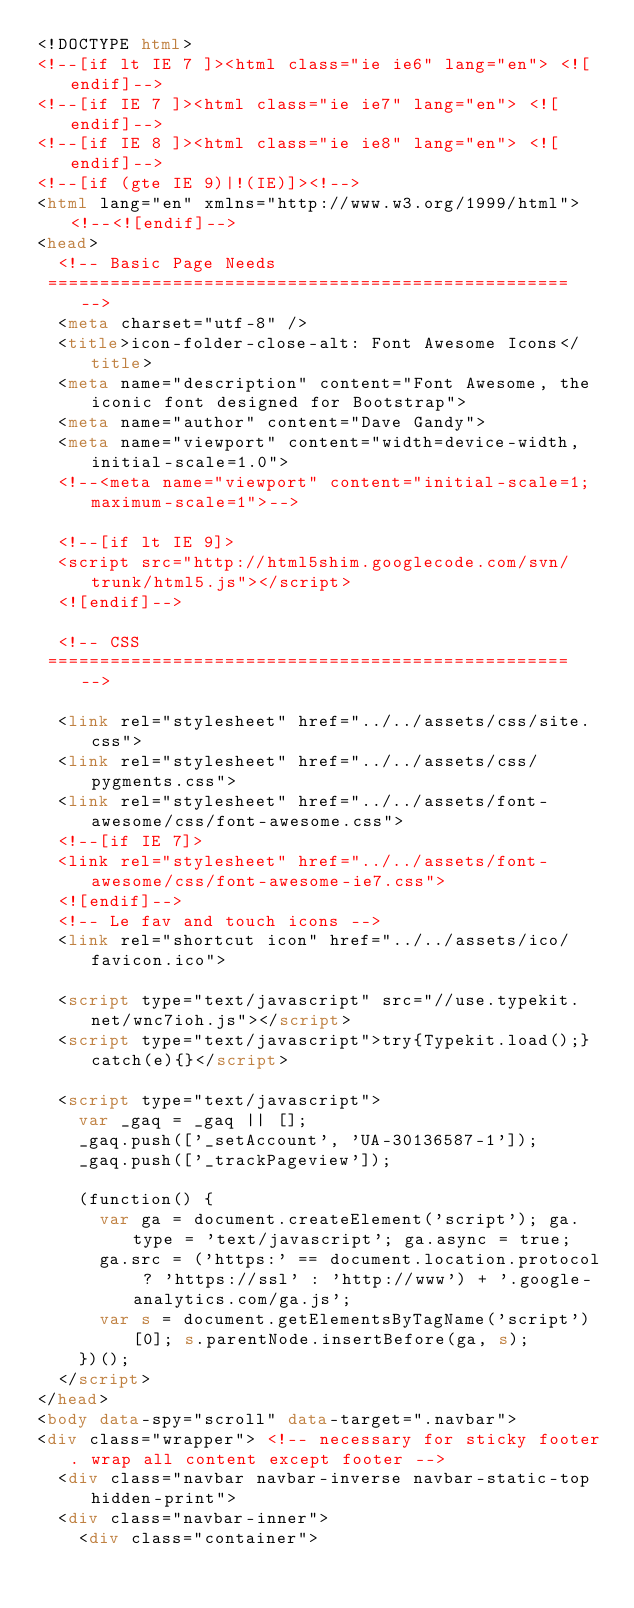Convert code to text. <code><loc_0><loc_0><loc_500><loc_500><_HTML_><!DOCTYPE html>
<!--[if lt IE 7 ]><html class="ie ie6" lang="en"> <![endif]-->
<!--[if IE 7 ]><html class="ie ie7" lang="en"> <![endif]-->
<!--[if IE 8 ]><html class="ie ie8" lang="en"> <![endif]-->
<!--[if (gte IE 9)|!(IE)]><!-->
<html lang="en" xmlns="http://www.w3.org/1999/html"> <!--<![endif]-->
<head>
  <!-- Basic Page Needs
 ================================================== -->
  <meta charset="utf-8" />
  <title>icon-folder-close-alt: Font Awesome Icons</title>
  <meta name="description" content="Font Awesome, the iconic font designed for Bootstrap">
  <meta name="author" content="Dave Gandy">
  <meta name="viewport" content="width=device-width, initial-scale=1.0">
  <!--<meta name="viewport" content="initial-scale=1; maximum-scale=1">-->

  <!--[if lt IE 9]>
  <script src="http://html5shim.googlecode.com/svn/trunk/html5.js"></script>
  <![endif]-->

  <!-- CSS
 ================================================== -->

  <link rel="stylesheet" href="../../assets/css/site.css">
  <link rel="stylesheet" href="../../assets/css/pygments.css">
  <link rel="stylesheet" href="../../assets/font-awesome/css/font-awesome.css">
  <!--[if IE 7]>
  <link rel="stylesheet" href="../../assets/font-awesome/css/font-awesome-ie7.css">
  <![endif]-->
  <!-- Le fav and touch icons -->
  <link rel="shortcut icon" href="../../assets/ico/favicon.ico">

  <script type="text/javascript" src="//use.typekit.net/wnc7ioh.js"></script>
  <script type="text/javascript">try{Typekit.load();}catch(e){}</script>

  <script type="text/javascript">
    var _gaq = _gaq || [];
    _gaq.push(['_setAccount', 'UA-30136587-1']);
    _gaq.push(['_trackPageview']);

    (function() {
      var ga = document.createElement('script'); ga.type = 'text/javascript'; ga.async = true;
      ga.src = ('https:' == document.location.protocol ? 'https://ssl' : 'http://www') + '.google-analytics.com/ga.js';
      var s = document.getElementsByTagName('script')[0]; s.parentNode.insertBefore(ga, s);
    })();
  </script>
</head>
<body data-spy="scroll" data-target=".navbar">
<div class="wrapper"> <!-- necessary for sticky footer. wrap all content except footer -->
  <div class="navbar navbar-inverse navbar-static-top hidden-print">
  <div class="navbar-inner">
    <div class="container"></code> 